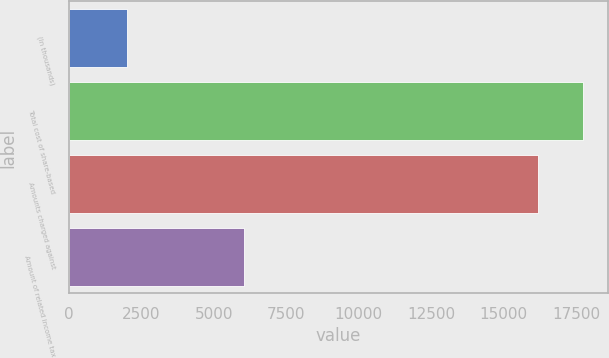Convert chart. <chart><loc_0><loc_0><loc_500><loc_500><bar_chart><fcel>(In thousands)<fcel>Total cost of share-based<fcel>Amounts charged against<fcel>Amount of related income tax<nl><fcel>2007<fcel>17721.7<fcel>16189<fcel>6030<nl></chart> 